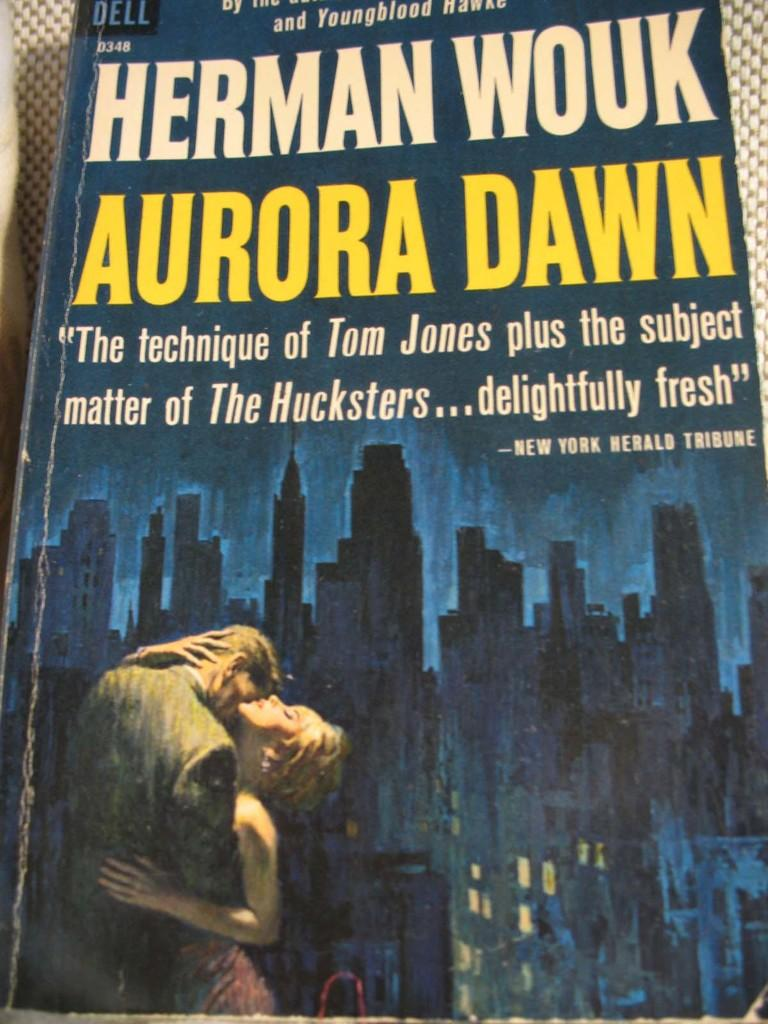<image>
Offer a succinct explanation of the picture presented. A blue book titled Aurora Dawn by Herman Wouk. 